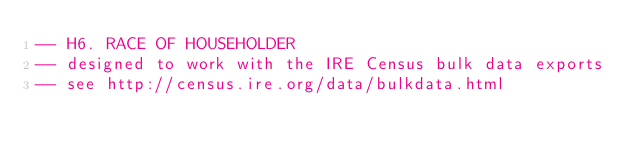<code> <loc_0><loc_0><loc_500><loc_500><_SQL_>-- H6. RACE OF HOUSEHOLDER
-- designed to work with the IRE Census bulk data exports
-- see http://census.ire.org/data/bulkdata.html</code> 